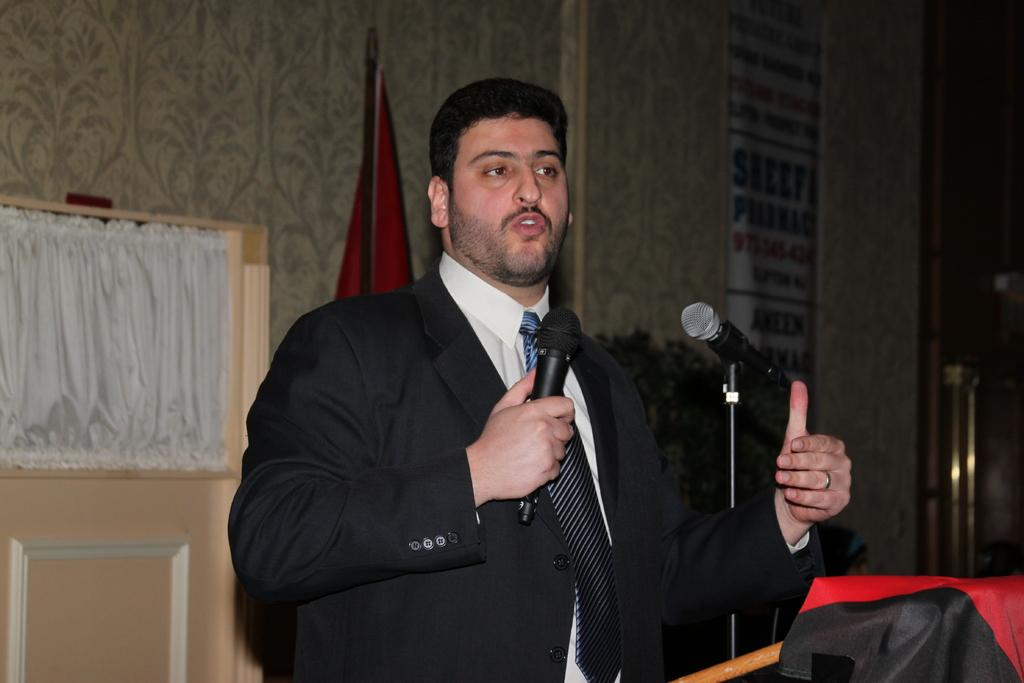What is the man in the image wearing? The man in the image is wearing a black suit and a tie. What is the man doing in the image? The man is talking in front of a microphone. What can be seen on the wall behind the man? There is a banner on the wall. What is the man holding while talking? There is a microphone with a stand beside the man, but he is not holding it. What other object related to speaking is present in the image? There is a microphone with a stand beside the man. What additional item can be seen in the image? There is a flag in the image. What type of wren can be seen perched on the man's shoulder in the image? There is no wren present in the image; the man is not accompanied by any birds. 